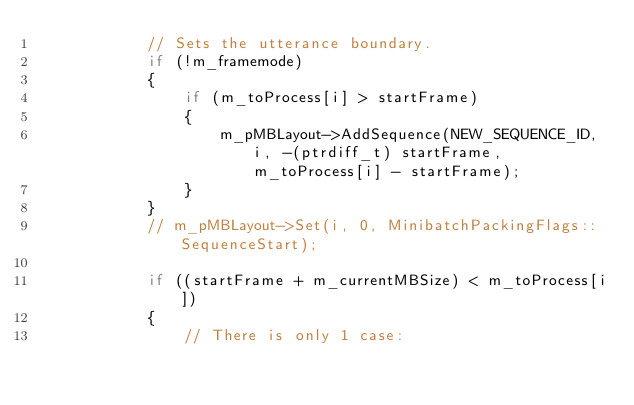Convert code to text. <code><loc_0><loc_0><loc_500><loc_500><_C++_>            // Sets the utterance boundary.
            if (!m_framemode)
            {
                if (m_toProcess[i] > startFrame)
                {
                    m_pMBLayout->AddSequence(NEW_SEQUENCE_ID, i, -(ptrdiff_t) startFrame, m_toProcess[i] - startFrame);
                }
            }
            // m_pMBLayout->Set(i, 0, MinibatchPackingFlags::SequenceStart);

            if ((startFrame + m_currentMBSize) < m_toProcess[i])
            {
                // There is only 1 case:</code> 